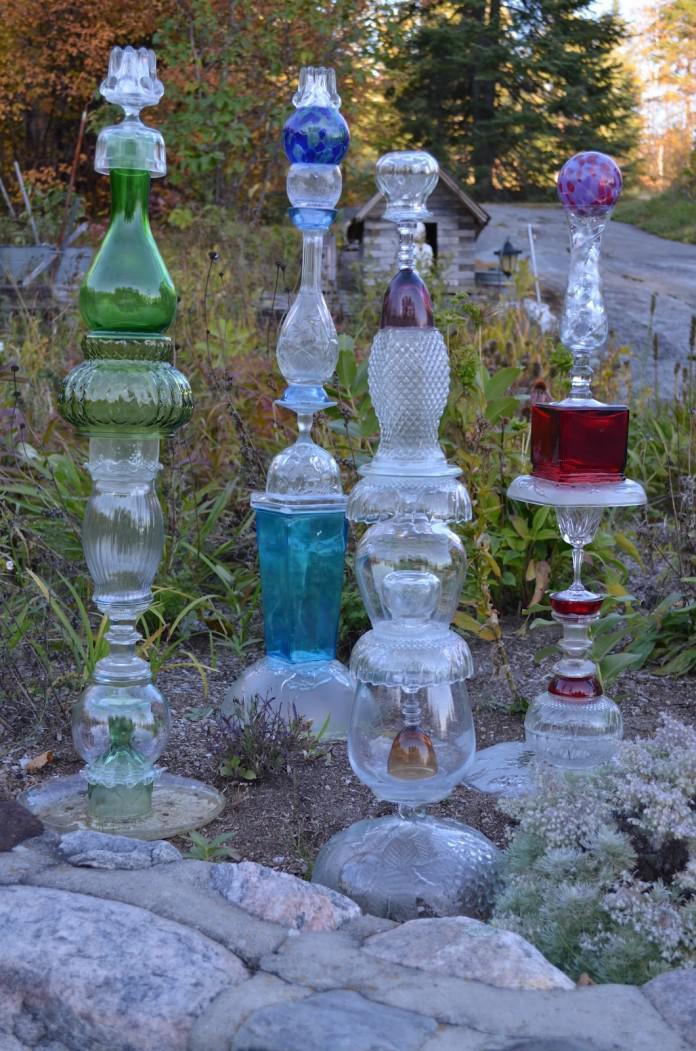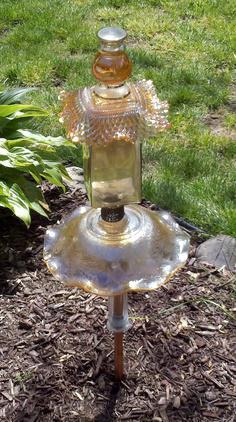The first image is the image on the left, the second image is the image on the right. Evaluate the accuracy of this statement regarding the images: "One image features a tower of stacked glass vases and pedestals in various colors, and the stacked glassware does not combine to form a human-like figure.". Is it true? Answer yes or no. Yes. The first image is the image on the left, the second image is the image on the right. Given the left and right images, does the statement "In at least one image there is a glass angel looking vase that is touch leaves and dirt on the ground." hold true? Answer yes or no. No. 